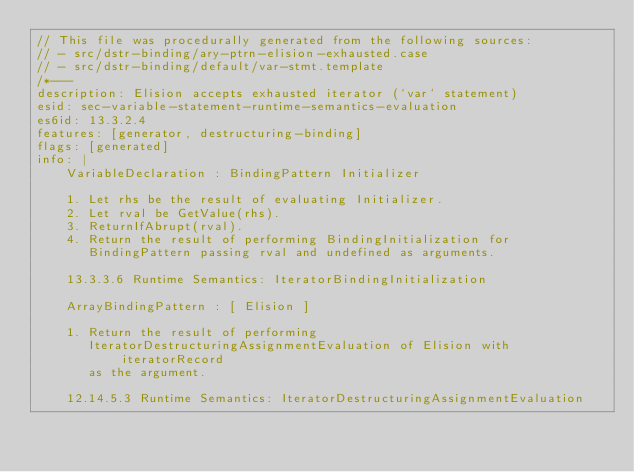Convert code to text. <code><loc_0><loc_0><loc_500><loc_500><_JavaScript_>// This file was procedurally generated from the following sources:
// - src/dstr-binding/ary-ptrn-elision-exhausted.case
// - src/dstr-binding/default/var-stmt.template
/*---
description: Elision accepts exhausted iterator (`var` statement)
esid: sec-variable-statement-runtime-semantics-evaluation
es6id: 13.3.2.4
features: [generator, destructuring-binding]
flags: [generated]
info: |
    VariableDeclaration : BindingPattern Initializer

    1. Let rhs be the result of evaluating Initializer.
    2. Let rval be GetValue(rhs).
    3. ReturnIfAbrupt(rval).
    4. Return the result of performing BindingInitialization for
       BindingPattern passing rval and undefined as arguments.

    13.3.3.6 Runtime Semantics: IteratorBindingInitialization

    ArrayBindingPattern : [ Elision ]

    1. Return the result of performing
       IteratorDestructuringAssignmentEvaluation of Elision with iteratorRecord
       as the argument.

    12.14.5.3 Runtime Semantics: IteratorDestructuringAssignmentEvaluation
</code> 